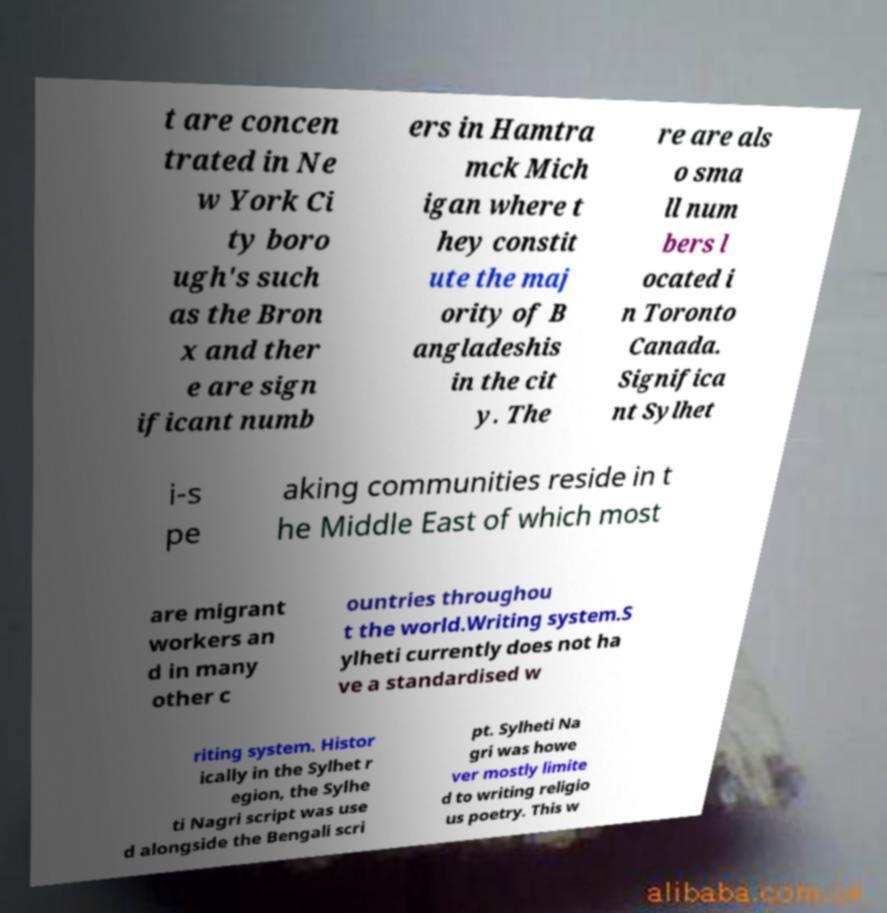For documentation purposes, I need the text within this image transcribed. Could you provide that? t are concen trated in Ne w York Ci ty boro ugh's such as the Bron x and ther e are sign ificant numb ers in Hamtra mck Mich igan where t hey constit ute the maj ority of B angladeshis in the cit y. The re are als o sma ll num bers l ocated i n Toronto Canada. Significa nt Sylhet i-s pe aking communities reside in t he Middle East of which most are migrant workers an d in many other c ountries throughou t the world.Writing system.S ylheti currently does not ha ve a standardised w riting system. Histor ically in the Sylhet r egion, the Sylhe ti Nagri script was use d alongside the Bengali scri pt. Sylheti Na gri was howe ver mostly limite d to writing religio us poetry. This w 